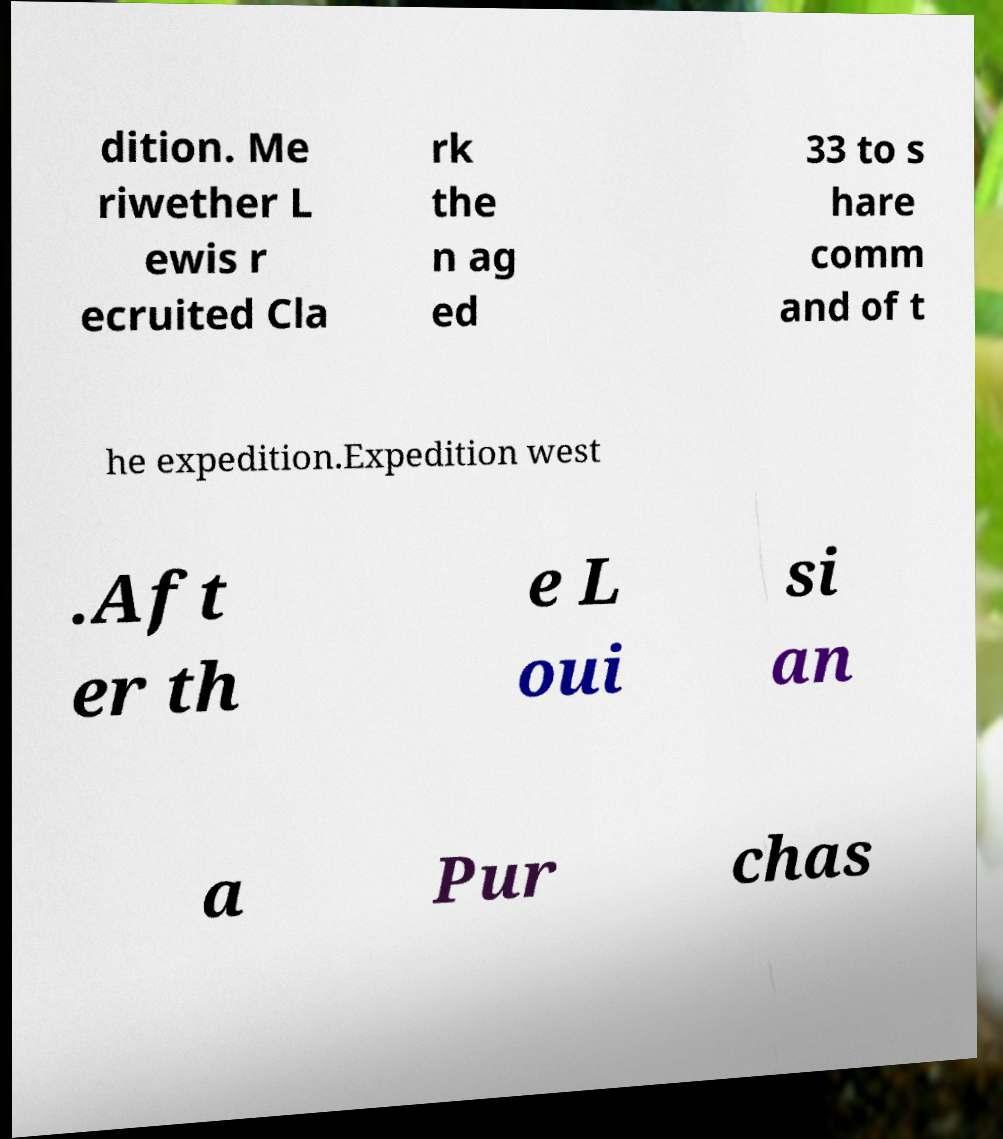Could you extract and type out the text from this image? dition. Me riwether L ewis r ecruited Cla rk the n ag ed 33 to s hare comm and of t he expedition.Expedition west .Aft er th e L oui si an a Pur chas 